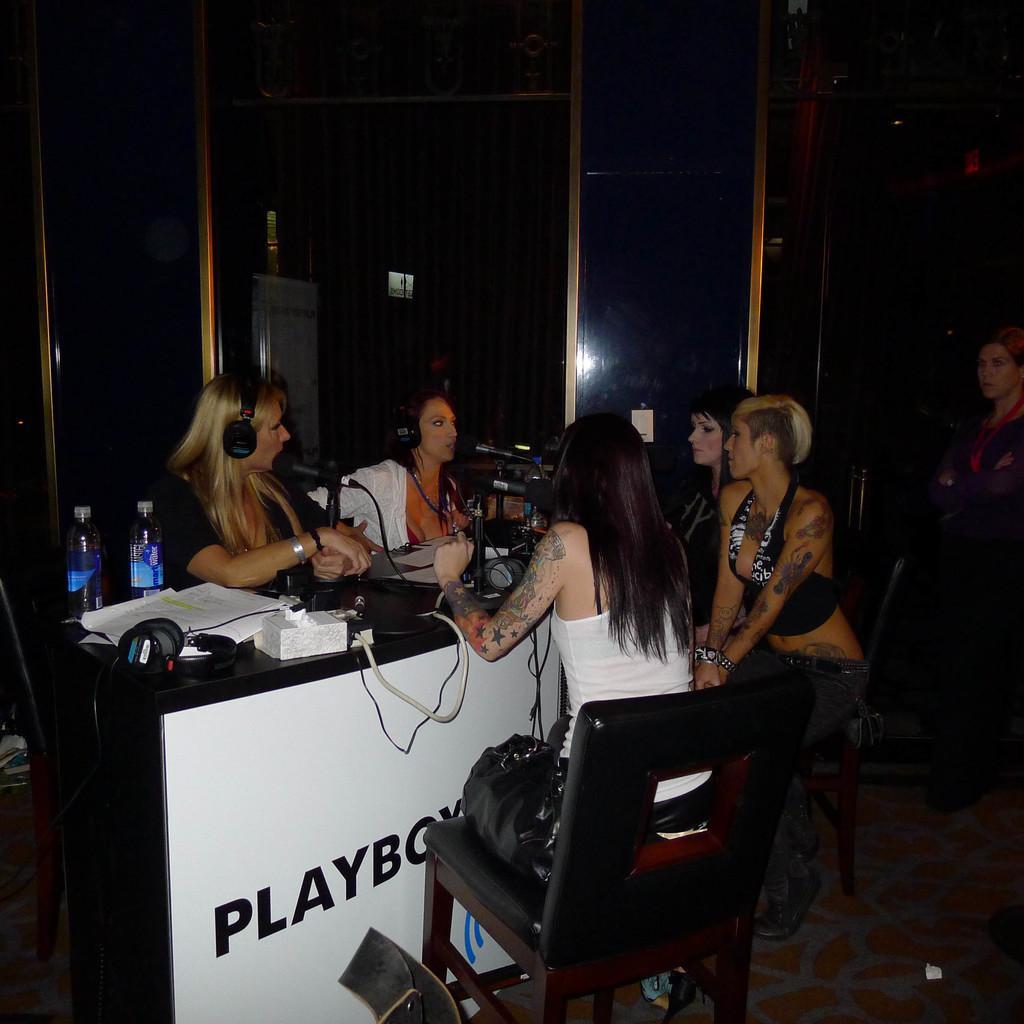Describe this image in one or two sentences. In this image I can see few women are sitting on chairs. On this table I can see few mics. In the background I can see one more woman. 